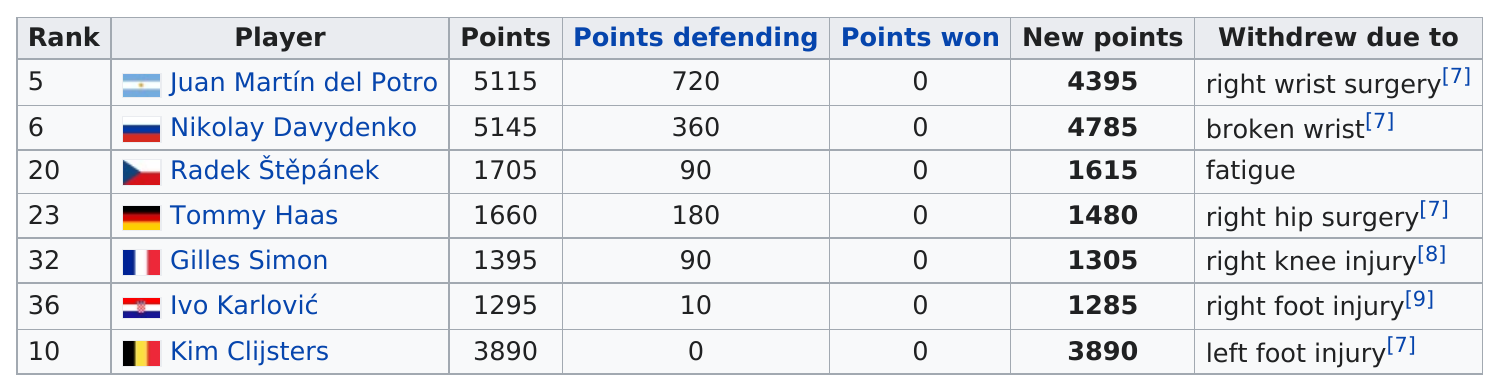Indicate a few pertinent items in this graphic. It is not the case that Gilles Simon was ranked higher than Tommy Haas. A total of two players were withdrawn due to surgery. Nikolay Davydenko is the tennis player who was first in terms of accumulating new points. Radek Štěpánek was the only player who withdrew from the 2010 French Open due to fatigue. Juan Martín del Potro was the highest-ranking player to withdraw from the 2010 French Open tournament. 